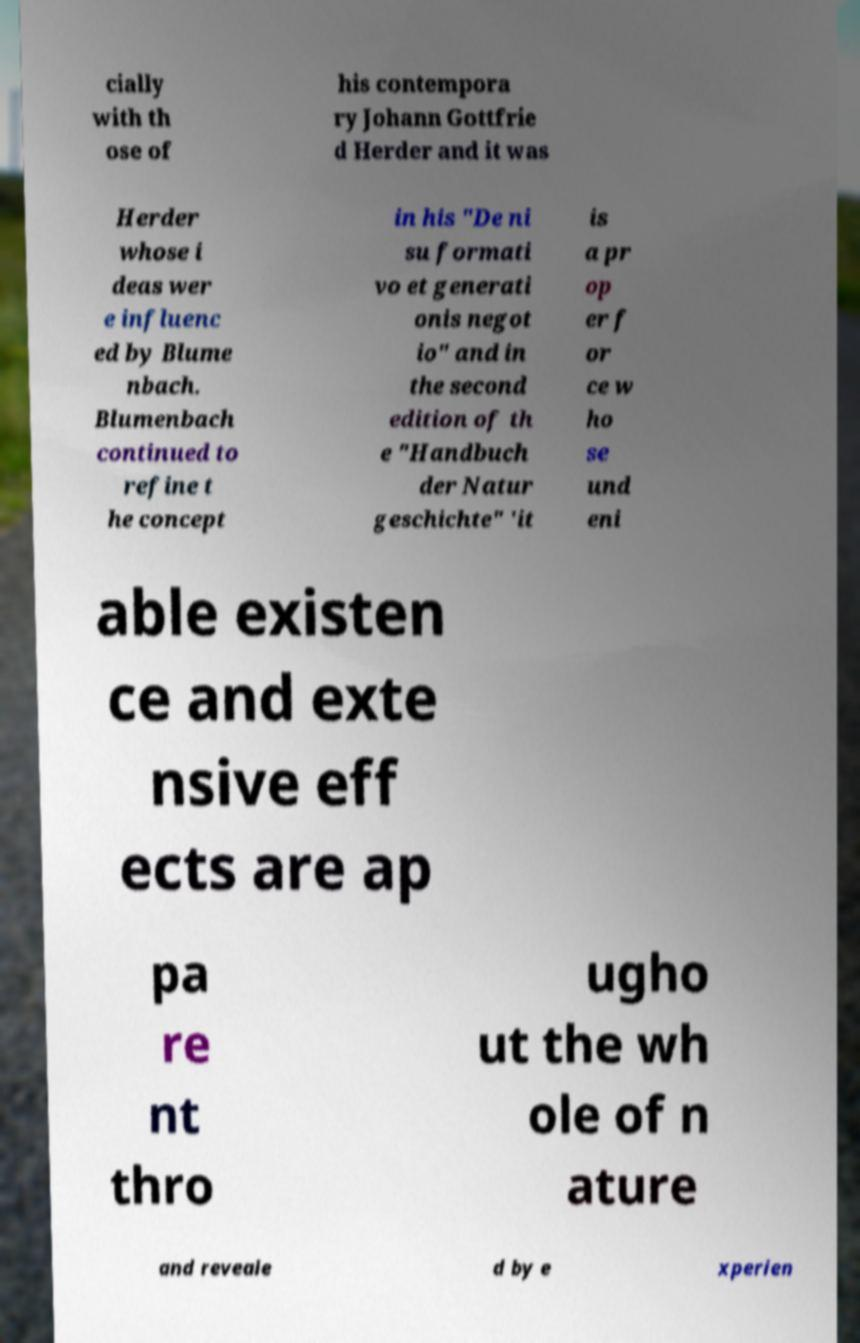I need the written content from this picture converted into text. Can you do that? cially with th ose of his contempora ry Johann Gottfrie d Herder and it was Herder whose i deas wer e influenc ed by Blume nbach. Blumenbach continued to refine t he concept in his "De ni su formati vo et generati onis negot io" and in the second edition of th e "Handbuch der Natur geschichte" 'it is a pr op er f or ce w ho se und eni able existen ce and exte nsive eff ects are ap pa re nt thro ugho ut the wh ole of n ature and reveale d by e xperien 